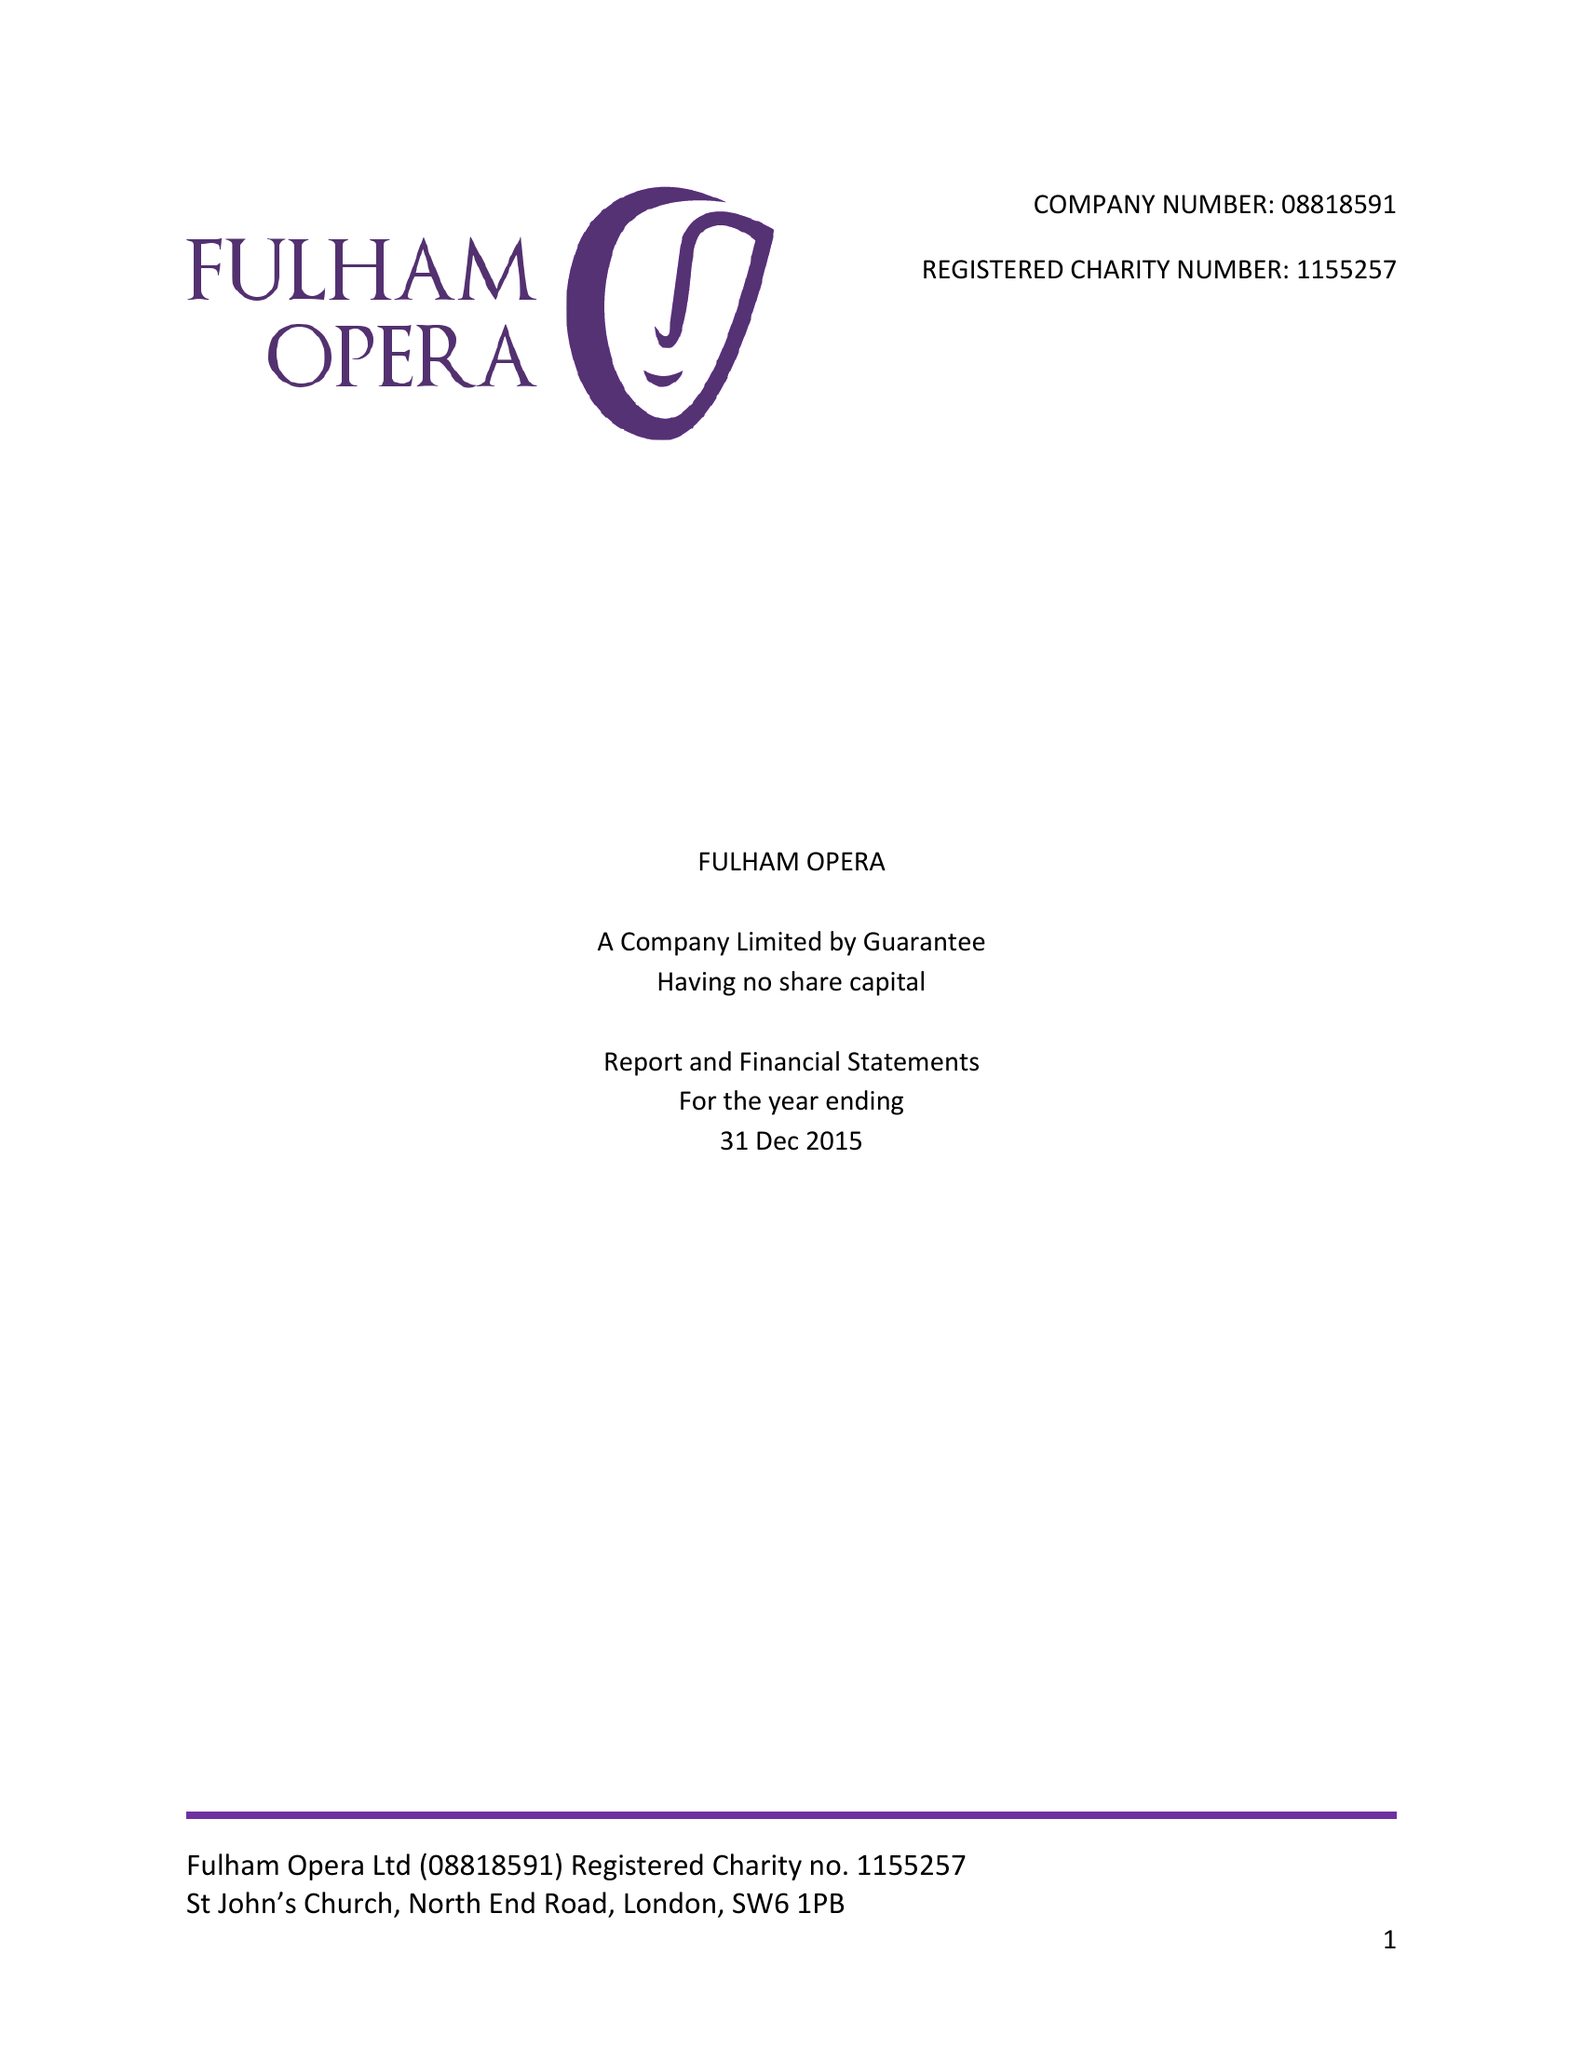What is the value for the address__street_line?
Answer the question using a single word or phrase. NORTH END ROAD 